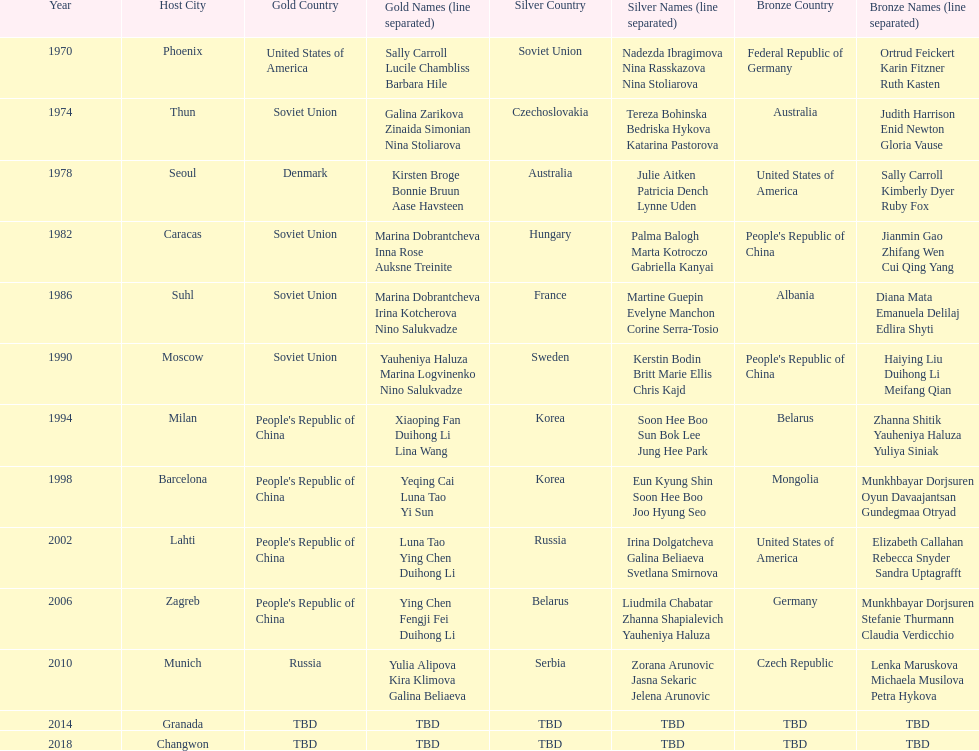What is the number of total bronze medals that germany has won? 1. 